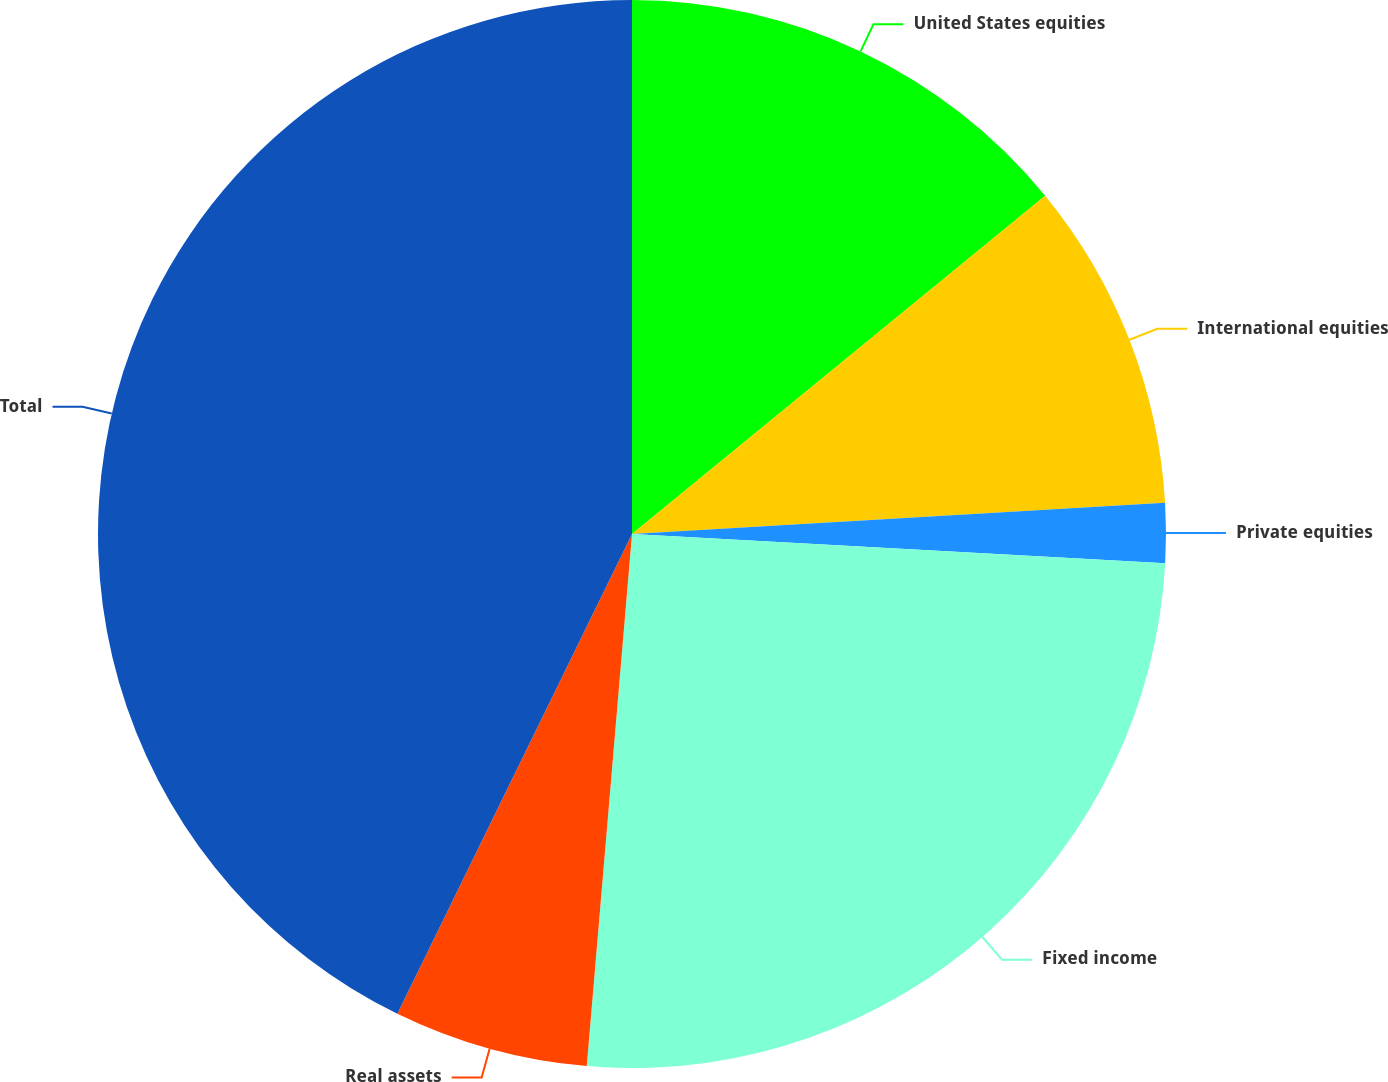<chart> <loc_0><loc_0><loc_500><loc_500><pie_chart><fcel>United States equities<fcel>International equities<fcel>Private equities<fcel>Fixed income<fcel>Real assets<fcel>Total<nl><fcel>14.08%<fcel>9.99%<fcel>1.8%<fcel>25.48%<fcel>5.89%<fcel>42.76%<nl></chart> 